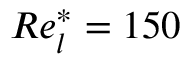<formula> <loc_0><loc_0><loc_500><loc_500>R e _ { l } ^ { * } = 1 5 0</formula> 